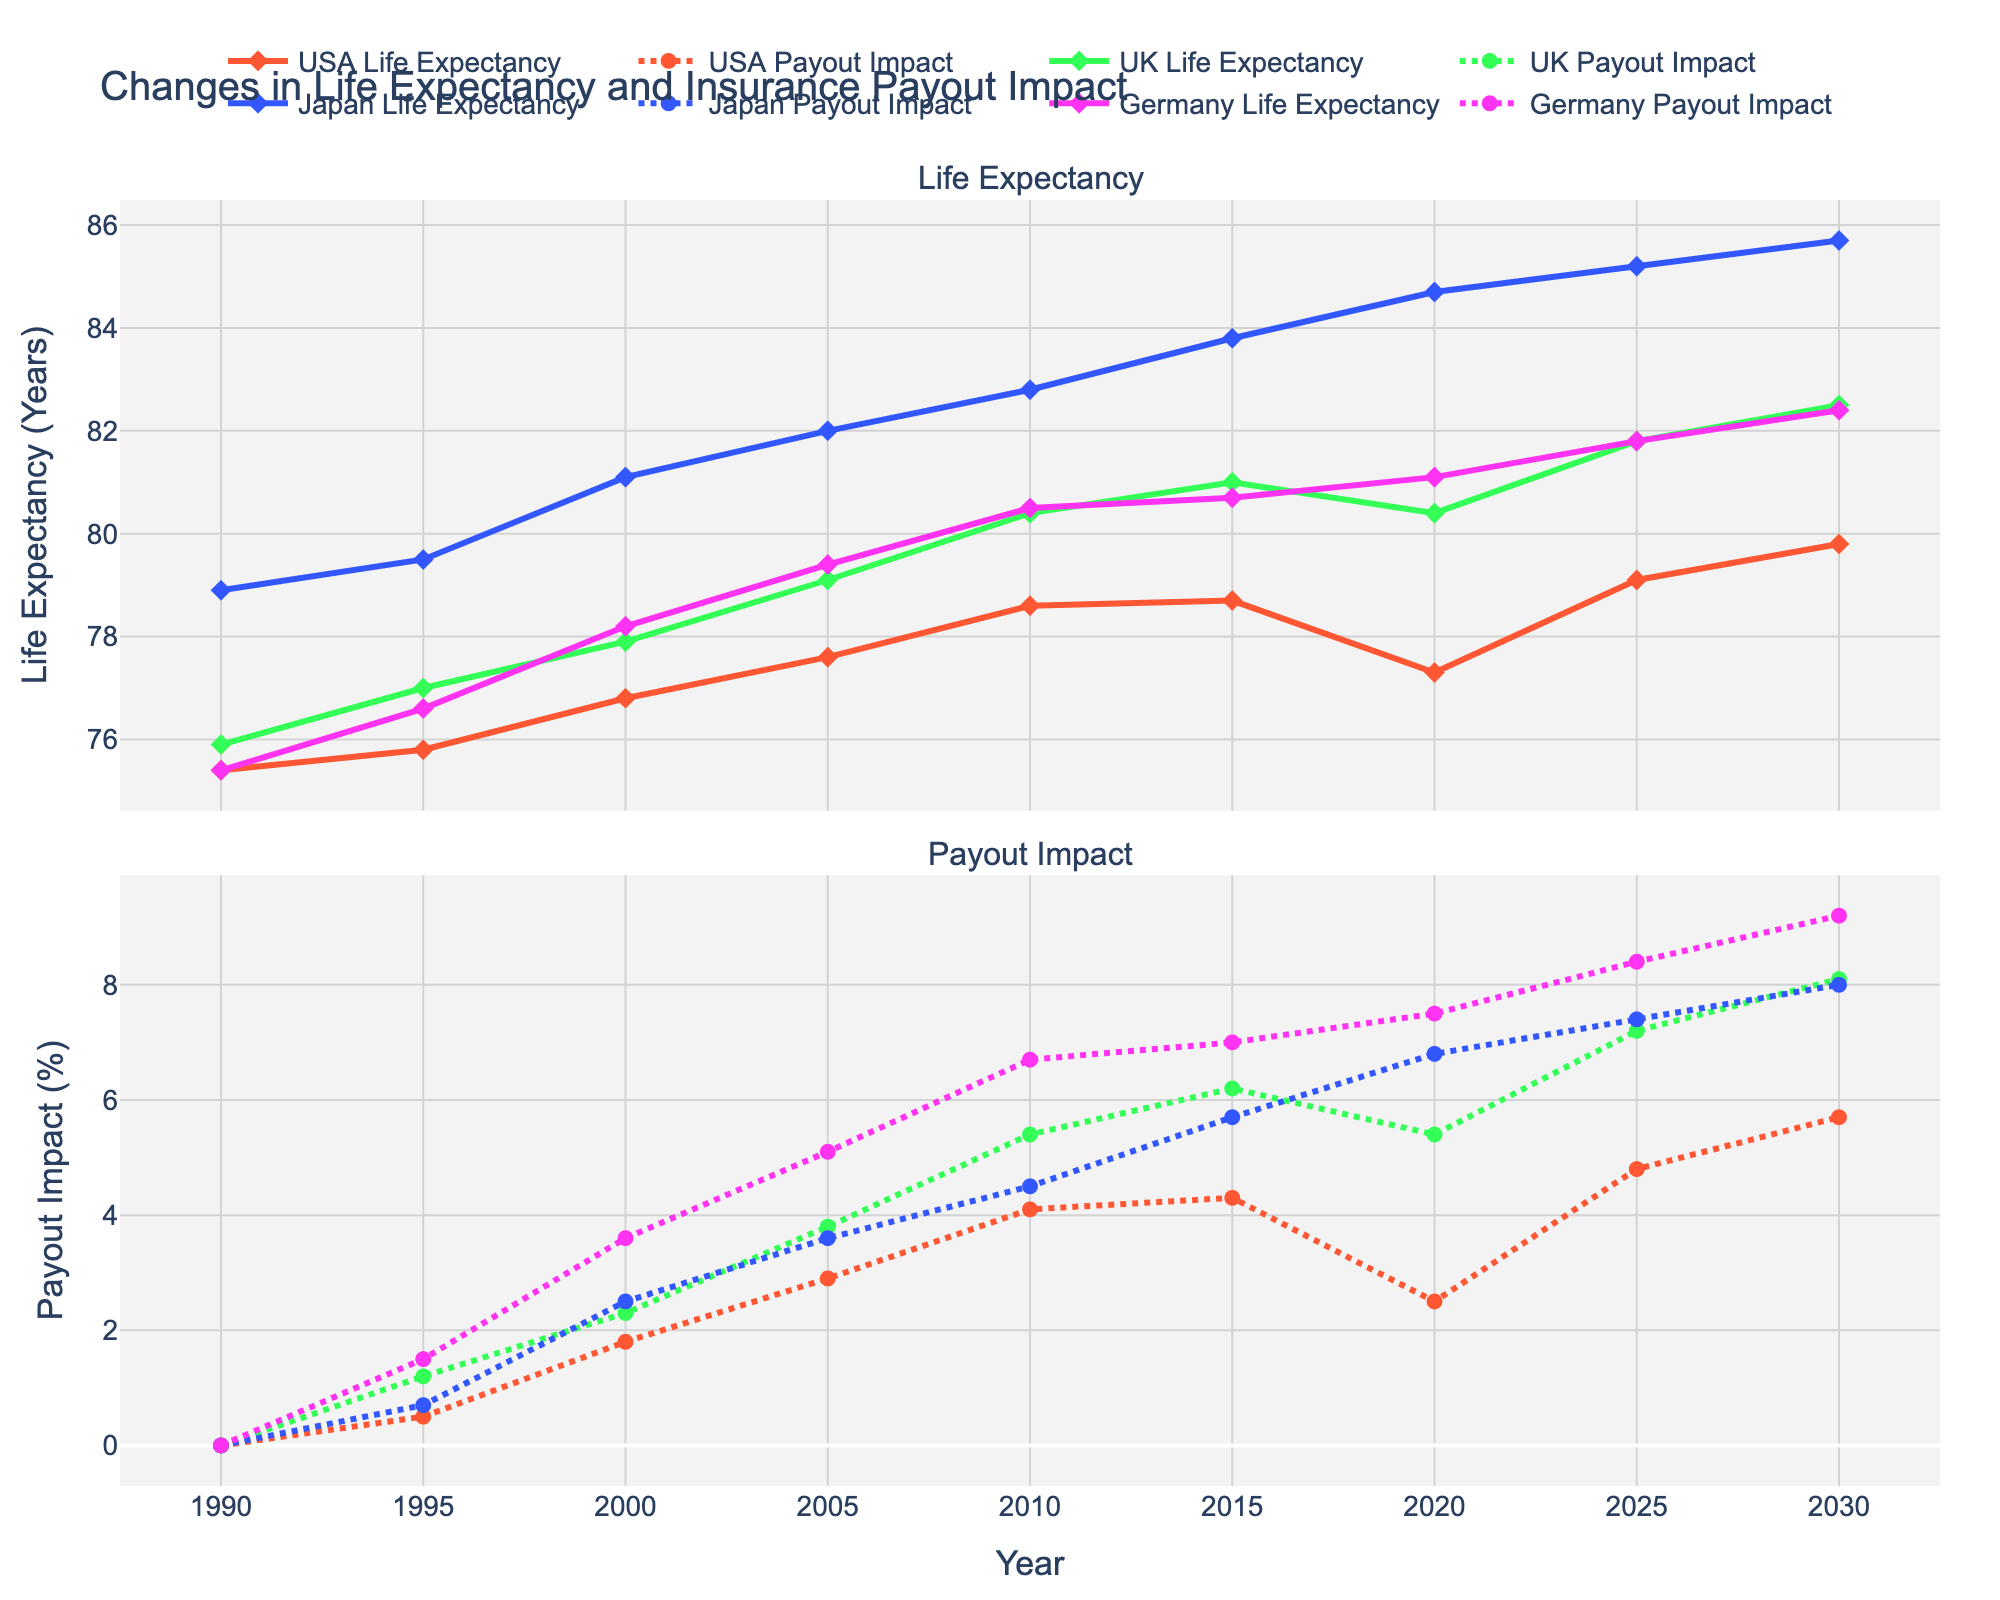Which country had the highest life expectancy in 2015? Look at the dataset for 2015 and identify the highest life expectancy among the USA, UK, Japan, and Germany. Japan has the highest value at 83.8 years.
Answer: Japan What was the payout impact percentage change from 2015 to 2020 in the USA? Extract the payout impact percentages for the USA in 2015 and 2020. Calculate the percentage change: 4.3% in 2015 to 2.5% in 2020. The change is 2.5% - 4.3% = -1.8%.
Answer: -1.8% Compare life expectancy trends between 1995 and 2030 for the UK and USA. For the UK, life expectancy increased from 77.0 in 1995 to 82.5 in 2030. For the USA, it increased from 75.8 in 1995 to 79.8 in 2030. The UK showed a greater increase (5.5 years) compared to the USA (4.0 years).
Answer: The UK has a higher increase Which country showed the highest payout impact percentage increase from 2010 to 2020? Subtract the payout impact percentages of 2010 from 2020 for all four countries and compare the differences. The increments are: USA: -1.6%, UK: 0%, Japan: 2.3%, Germany: 0.8%. Japan had the highest increase.
Answer: Japan What is the average life expectancy in Germany from 2000 to 2020? Calculate the average of Germany's life expectancy in the given years: (78.2 + 79.4 + 80.5 + 80.7 + 81.1) / 5 = 399.9 / 5.0 = 79.98.
Answer: 79.98 years How does the payout impact correlate with life expectancy changes in Japan from 1990 to 2030? Notice the consistent increase in both life expectancy and payout impact percentages over the years. For Japan, life expectancy increases from 78.9 to 85.7, and payout impact increases from 0% to 8.0%, indicating a positive correlation.
Answer: Positive correlation In 2020, which country had the smallest payout impact percentage, and what is its value? Look for the payout impact percentages for 2020. The USA has the smallest value of 2.5%.
Answer: USA, 2.5% Compare the trends of life expectancy and payout impact for Germany between 2010 and 2025. Germany's life expectancy increases from 80.5 to 81.8 (a 1.3-year increase), and payout impact increases from 6.7% to 8.4% (a 1.7% increase). Both trends show a steady increase.
Answer: Both trends increased steadily Which country's payout impact percentage in 2000 was closest to Germany's payout in 2020? Compare Germany's 2020 payout (7.5%) with other countries' 2000 payouts. The UK has a 2000 payout impact percentage of 2.3%, USA 1.8%, Japan 2.5%, and Germany's own 7.5%. No country's 2000 payout is close to Germany's 2020 value.
Answer: None 